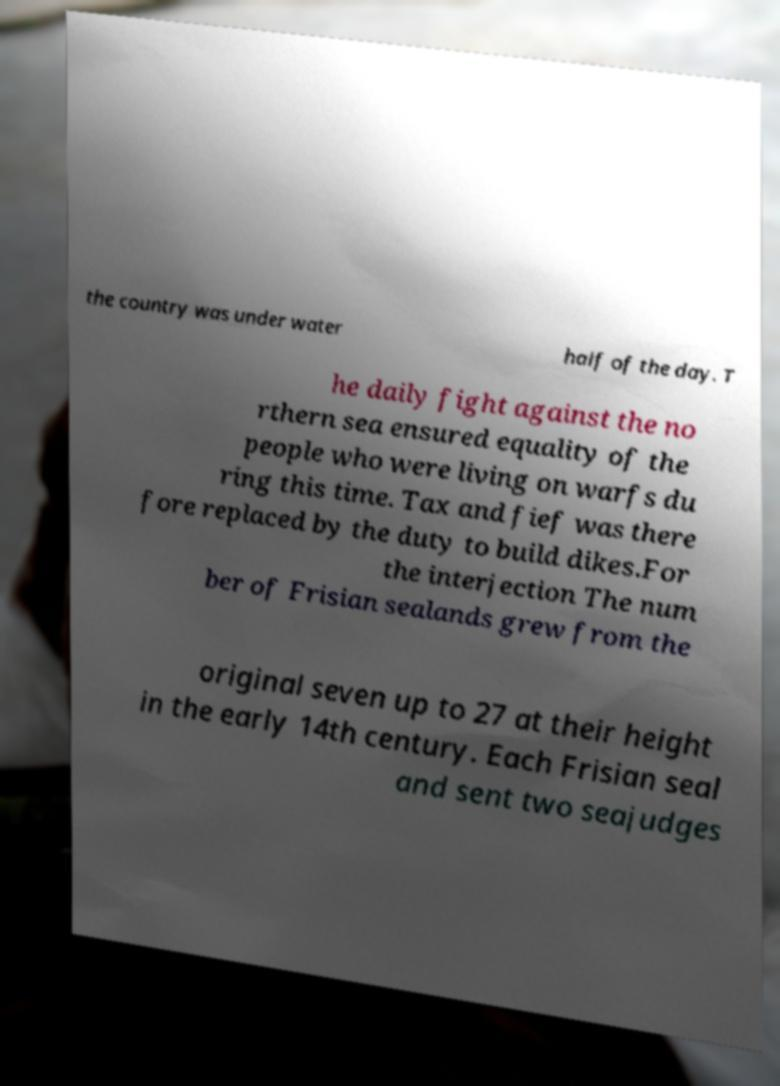Can you read and provide the text displayed in the image?This photo seems to have some interesting text. Can you extract and type it out for me? the country was under water half of the day. T he daily fight against the no rthern sea ensured equality of the people who were living on warfs du ring this time. Tax and fief was there fore replaced by the duty to build dikes.For the interjection The num ber of Frisian sealands grew from the original seven up to 27 at their height in the early 14th century. Each Frisian seal and sent two seajudges 